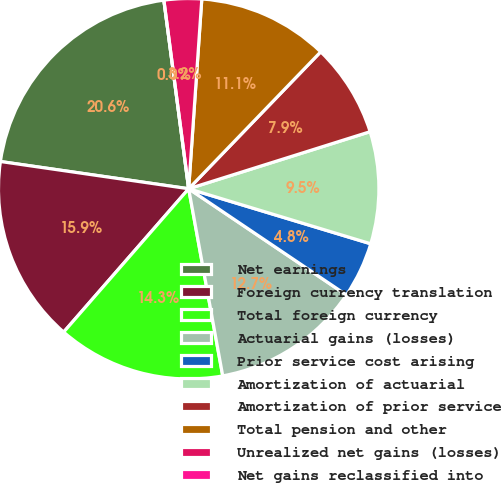Convert chart to OTSL. <chart><loc_0><loc_0><loc_500><loc_500><pie_chart><fcel>Net earnings<fcel>Foreign currency translation<fcel>Total foreign currency<fcel>Actuarial gains (losses)<fcel>Prior service cost arising<fcel>Amortization of actuarial<fcel>Amortization of prior service<fcel>Total pension and other<fcel>Unrealized net gains (losses)<fcel>Net gains reclassified into<nl><fcel>20.63%<fcel>15.87%<fcel>14.28%<fcel>12.7%<fcel>4.76%<fcel>9.52%<fcel>7.94%<fcel>11.11%<fcel>3.18%<fcel>0.0%<nl></chart> 